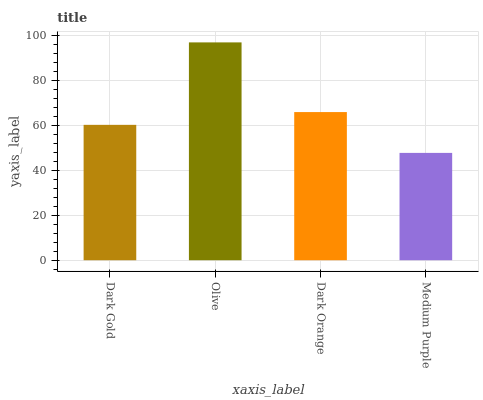Is Medium Purple the minimum?
Answer yes or no. Yes. Is Olive the maximum?
Answer yes or no. Yes. Is Dark Orange the minimum?
Answer yes or no. No. Is Dark Orange the maximum?
Answer yes or no. No. Is Olive greater than Dark Orange?
Answer yes or no. Yes. Is Dark Orange less than Olive?
Answer yes or no. Yes. Is Dark Orange greater than Olive?
Answer yes or no. No. Is Olive less than Dark Orange?
Answer yes or no. No. Is Dark Orange the high median?
Answer yes or no. Yes. Is Dark Gold the low median?
Answer yes or no. Yes. Is Medium Purple the high median?
Answer yes or no. No. Is Medium Purple the low median?
Answer yes or no. No. 